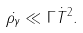Convert formula to latex. <formula><loc_0><loc_0><loc_500><loc_500>\dot { \rho _ { \gamma } } \ll \Gamma { \dot { T } } ^ { 2 } .</formula> 